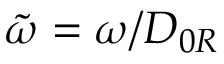Convert formula to latex. <formula><loc_0><loc_0><loc_500><loc_500>\tilde { \omega } = { \omega } / { D _ { 0 R } }</formula> 